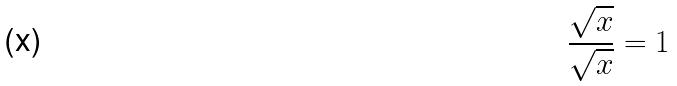<formula> <loc_0><loc_0><loc_500><loc_500>\frac { \sqrt { x } } { \sqrt { x } } = 1</formula> 